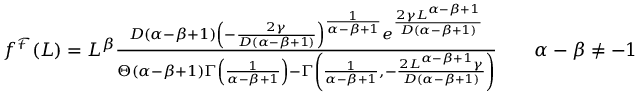<formula> <loc_0><loc_0><loc_500><loc_500>\begin{array} { r } { f ^ { \mathcal { F } } ( L ) = L ^ { \beta } \frac { D ( \alpha - \beta + 1 ) \left ( - \frac { 2 \gamma } { D ( \alpha - \beta + 1 ) } \right ) ^ { \frac { 1 } { \alpha - \beta + 1 } } e ^ { \frac { 2 \gamma L ^ { \alpha - \beta + 1 } } { D ( \alpha - \beta + 1 ) } } } { \Theta ( \alpha - \beta + 1 ) \Gamma \left ( \frac { 1 } { \alpha - \beta + 1 } \right ) - \Gamma \left ( \frac { 1 } { \alpha - \beta + 1 } , - \frac { 2 L ^ { \alpha - \beta + 1 } \gamma } { D ( \alpha - \beta + 1 ) } \right ) } \quad \alpha - \beta \neq - 1 \ . } \end{array}</formula> 